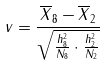<formula> <loc_0><loc_0><loc_500><loc_500>v = \frac { \overline { X } _ { 8 } - \overline { X } _ { 2 } } { \sqrt { \frac { h _ { 8 } ^ { 2 } } { N _ { 8 } } \cdot \frac { h _ { 2 } ^ { 2 } } { N _ { 2 } } } }</formula> 